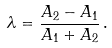Convert formula to latex. <formula><loc_0><loc_0><loc_500><loc_500>\lambda = \frac { A _ { 2 } - A _ { 1 } } { A _ { 1 } + A _ { 2 } } \, .</formula> 